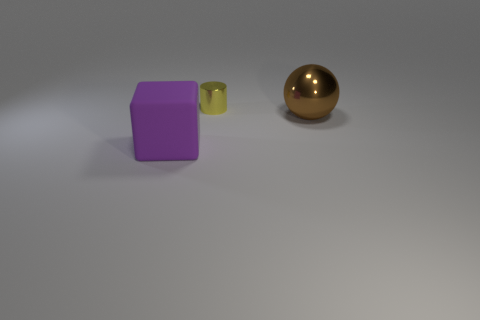Add 2 large yellow matte balls. How many objects exist? 5 Subtract all red cubes. Subtract all brown spheres. How many cubes are left? 1 Subtract all balls. How many objects are left? 2 Add 1 big brown metallic blocks. How many big brown metallic blocks exist? 1 Subtract 0 gray blocks. How many objects are left? 3 Subtract all large red rubber cylinders. Subtract all rubber blocks. How many objects are left? 2 Add 3 blocks. How many blocks are left? 4 